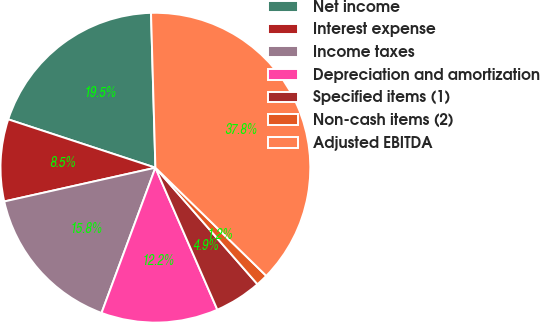<chart> <loc_0><loc_0><loc_500><loc_500><pie_chart><fcel>Net income<fcel>Interest expense<fcel>Income taxes<fcel>Depreciation and amortization<fcel>Specified items (1)<fcel>Non-cash items (2)<fcel>Adjusted EBITDA<nl><fcel>19.5%<fcel>8.55%<fcel>15.85%<fcel>12.2%<fcel>4.9%<fcel>1.25%<fcel>37.76%<nl></chart> 